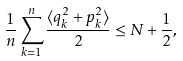<formula> <loc_0><loc_0><loc_500><loc_500>\frac { 1 } { n } \sum _ { k = 1 } ^ { n } \frac { \langle q _ { k } ^ { 2 } + p _ { k } ^ { 2 } \rangle } { 2 } \leq N + \frac { 1 } { 2 } ,</formula> 